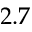Convert formula to latex. <formula><loc_0><loc_0><loc_500><loc_500>2 . 7</formula> 